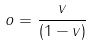<formula> <loc_0><loc_0><loc_500><loc_500>o = \frac { v } { ( 1 - v ) }</formula> 